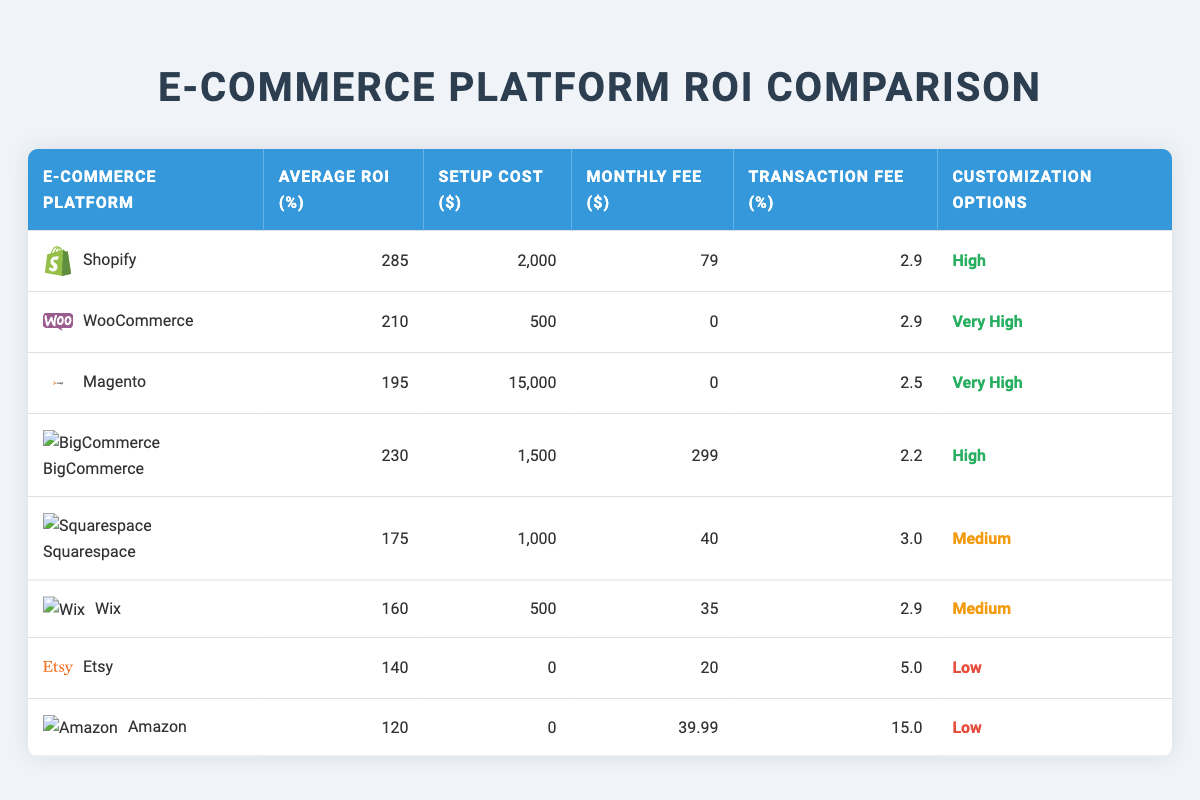What is the average ROI of Shopify and WooCommerce? The average ROI of Shopify is 285%, and for WooCommerce, it is 210%. To find the average, add both ROIs together and divide by 2: (285 + 210) / 2 = 247.5%
Answer: 247.5% Which platform has the lowest setup cost? The setup cost for Etsy and Amazon is $0, which is the lowest among all platforms listed in the table
Answer: $0 Is BigCommerce more expensive in monthly fees than Squarespace? The monthly fee for BigCommerce is $299, and for Squarespace, it is $40. Since $299 is greater than $40, BigCommerce indeed has higher monthly fees
Answer: Yes What is the monthly fee for WooCommerce? The monthly fee for WooCommerce is listed as $0 in the table
Answer: $0 If you combine the average ROIs of platforms with high customization options, what would be the sum? The platforms with high customization options are Shopify (285), BigCommerce (230), and WooCommerce (210). Their sum is (285 + 230 + 210) = 725
Answer: 725 Which platform has the highest transaction fee? The transaction fee for Amazon is 15.0%, which is the highest among all platforms listed
Answer: 15.0% Is there any platform that requires a monthly fee of $0? The table shows that WooCommerce and Etsy both have a monthly fee of $0
Answer: Yes What is the average setup cost of the platforms that have medium customization options? The platforms with medium customization options are Squarespace ($1000) and Wix ($500). To get the average, sum both setup costs and divide by 2: (1000 + 500) / 2 = 750
Answer: 750 If you were to choose a platform with the highest average ROI but relatively lower transaction fees, which one would it be? Shopify has the highest average ROI of 285% and a transaction fee of 2.9%, which is lower compared to the other platforms with high ROI
Answer: Shopify 